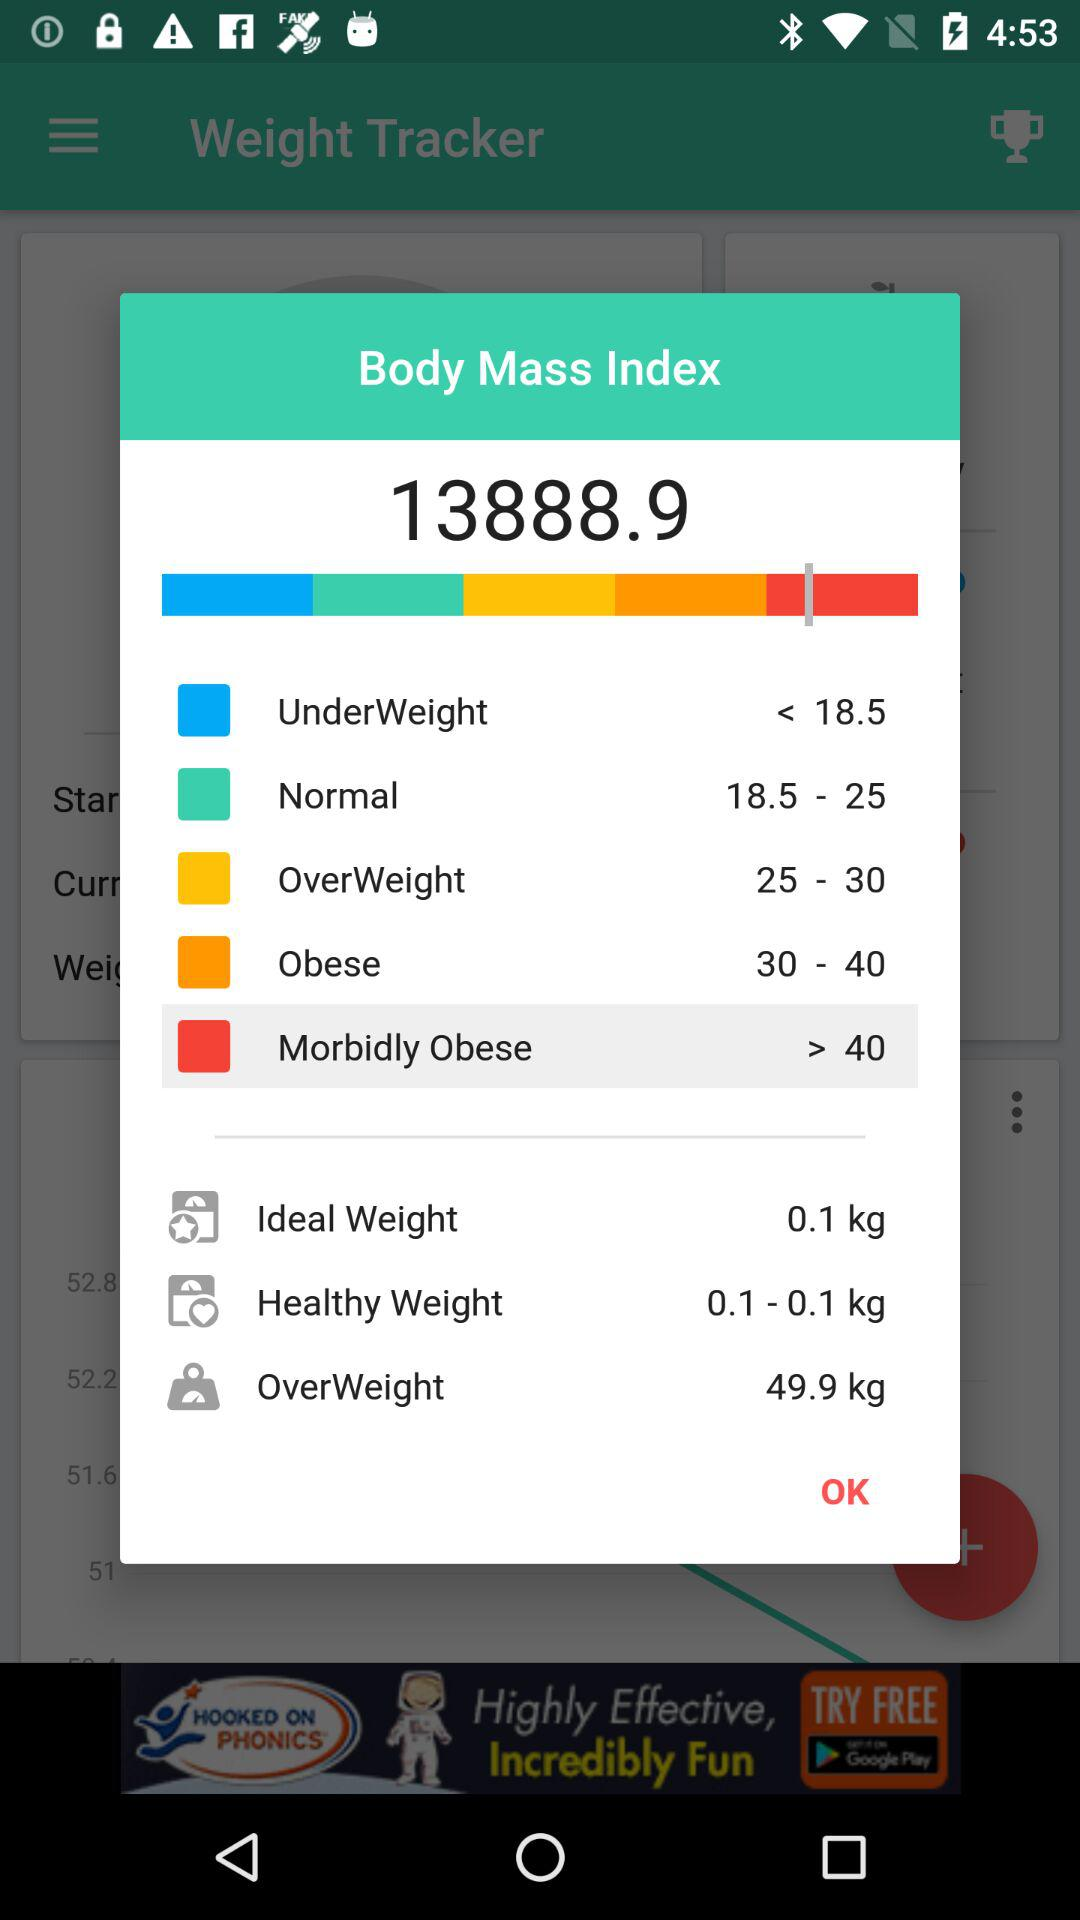What is the body mass index ratio? The body mass index ratio is 13888.9. 